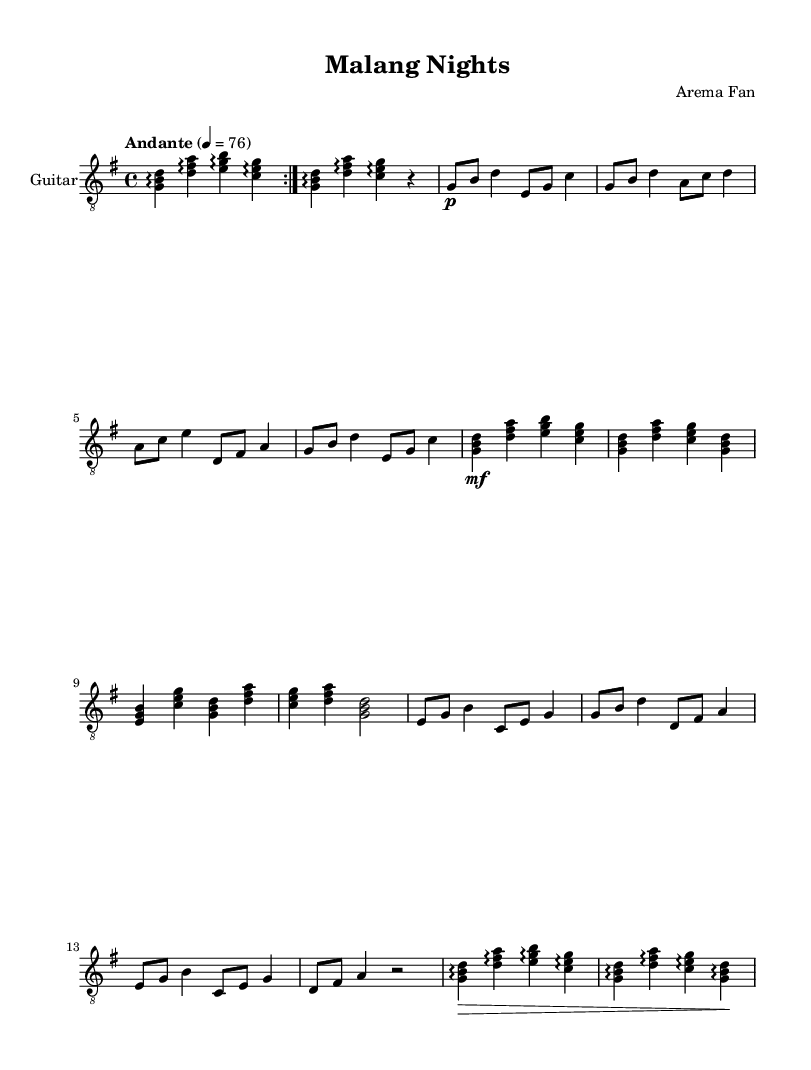What is the key signature of this music? The key signature is G major, which has one sharp (F#). This can be determined by looking for the symbols at the beginning of the staff line.
Answer: G major What is the time signature of this music? The time signature is 4/4, which indicates four beats per measure. This is found at the beginning of the score next to the key signature.
Answer: 4/4 What is the tempo marking of this song? The tempo marking is "Andante," which suggests a moderately slow pace. This is noted in the score where it specifies the tempo instruction for performance.
Answer: Andante How many sections are present in this score? The score consists of five sections: Intro, Verse, Chorus, Bridge, and Outro. This can be seen by identifying the labeled sections within the music.
Answer: Five What is the dynamic marking used in the chorus? The dynamic marking in the chorus is "mf," which stands for mezzo-forte, meaning moderately loud. The marking is found in the section of the score where the chorus begins.
Answer: mf In the bridge, what chord is the first one played? The first chord in the bridge is E minor. This can be discerned by looking at the notes aligned vertically in the score during the bridge section.
Answer: E minor Which instrument is specified for this score? The specified instrument is Acoustic Guitar (nylon). This is indicated in the part of the score where the instrument name is mentioned.
Answer: Acoustic Guitar (nylon) 